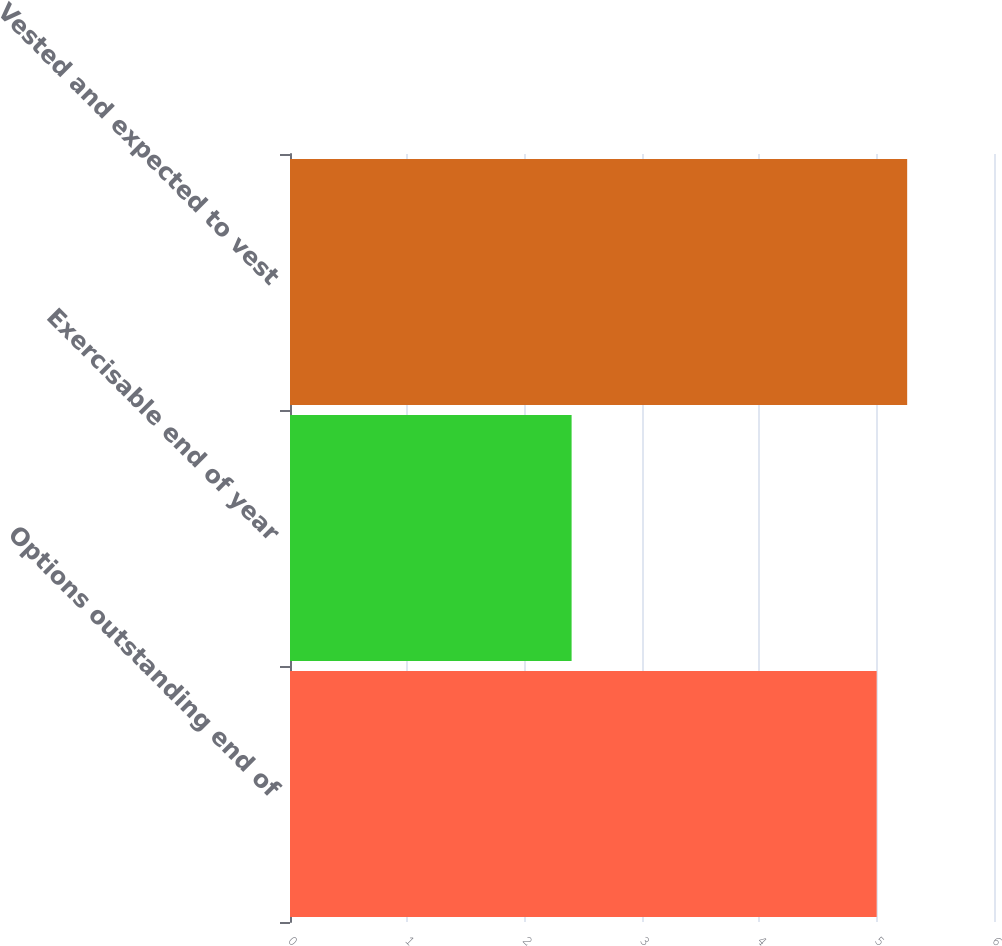<chart> <loc_0><loc_0><loc_500><loc_500><bar_chart><fcel>Options outstanding end of<fcel>Exercisable end of year<fcel>Vested and expected to vest<nl><fcel>5<fcel>2.4<fcel>5.26<nl></chart> 